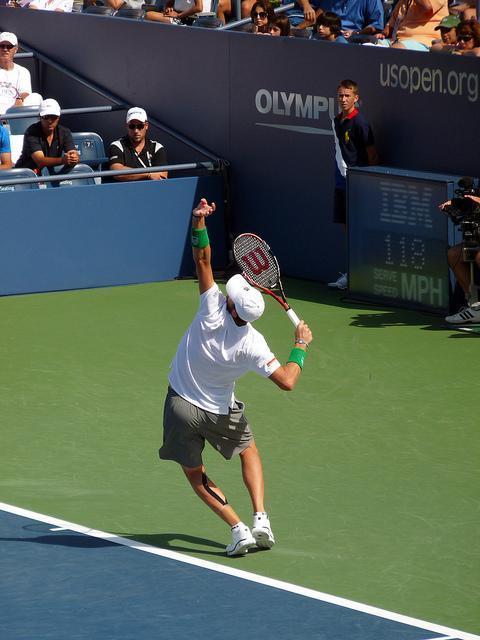How many tennis rackets are there?
Give a very brief answer. 1. How many people are in the photo?
Give a very brief answer. 4. 